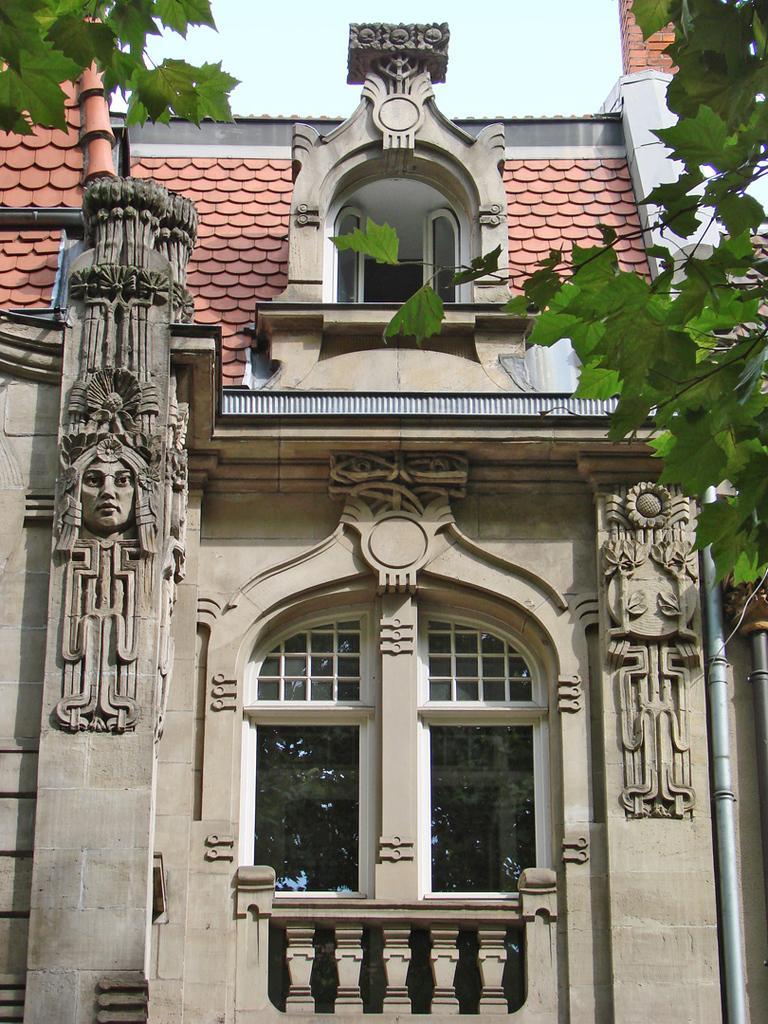Could you give a brief overview of what you see in this image? In this image there is a building. There are windows, sculptures and leaves. 